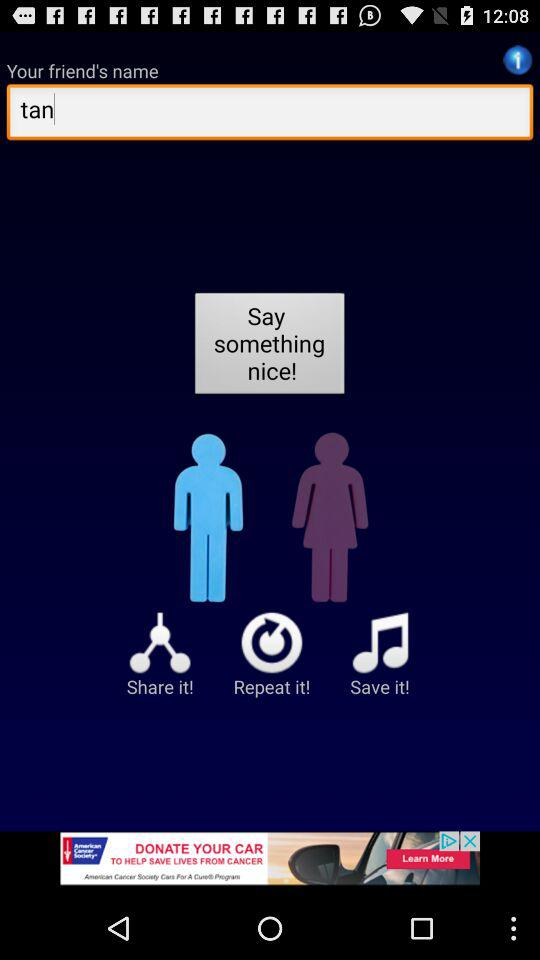What is the friend's name? The friend's name is Tan. 